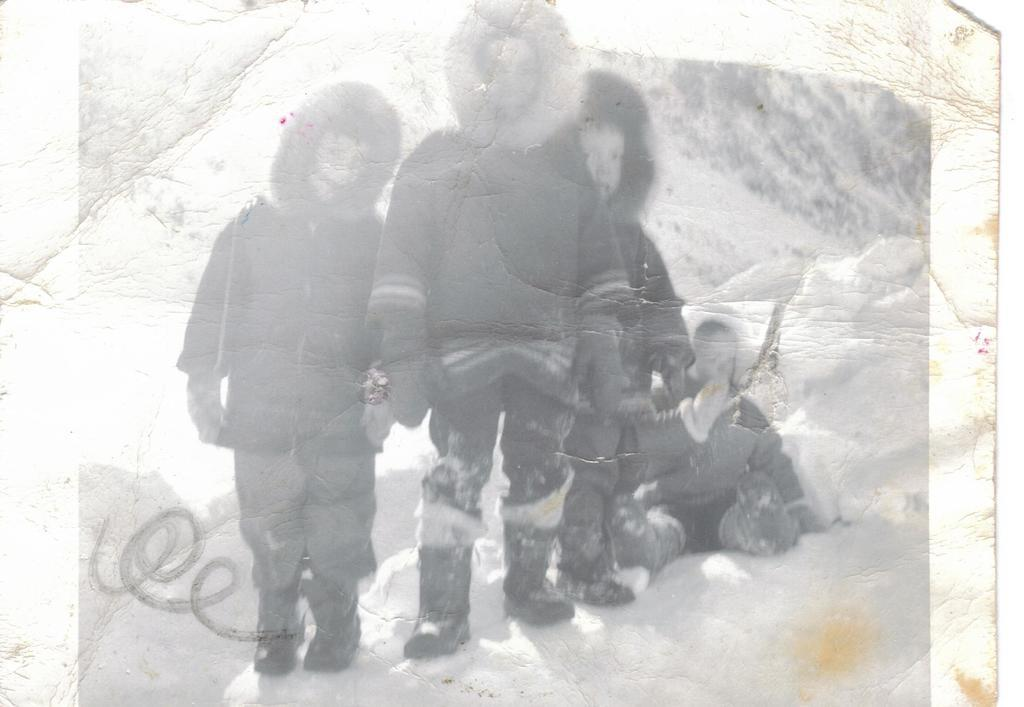What is the color scheme of the image? The image is black and white. Who or what is the main subject of the image? There are children in the image. Can you describe the background of the image? The background of the image is blurred. What type of curve can be seen in the image? There is no curve present in the image; it is a black and white image featuring children with a blurred background. 